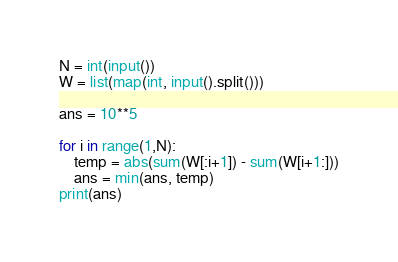<code> <loc_0><loc_0><loc_500><loc_500><_Python_>N = int(input())
W = list(map(int, input().split()))

ans = 10**5

for i in range(1,N):
    temp = abs(sum(W[:i+1]) - sum(W[i+1:]))
    ans = min(ans, temp)
print(ans)</code> 